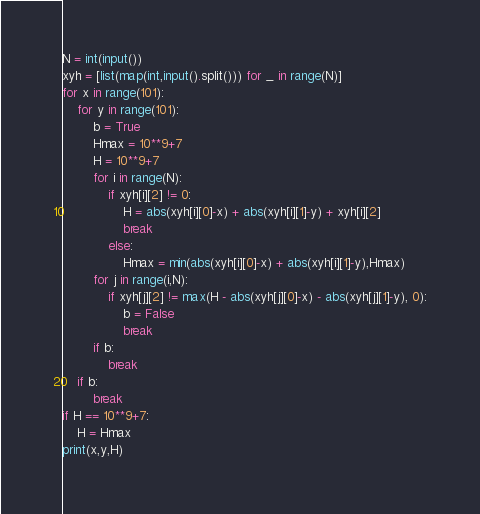Convert code to text. <code><loc_0><loc_0><loc_500><loc_500><_Python_>N = int(input())
xyh = [list(map(int,input().split())) for _ in range(N)]
for x in range(101):
    for y in range(101):
        b = True
        Hmax = 10**9+7
        H = 10**9+7
        for i in range(N):
            if xyh[i][2] != 0:
                H = abs(xyh[i][0]-x) + abs(xyh[i][1]-y) + xyh[i][2]
                break
            else:
                Hmax = min(abs(xyh[i][0]-x) + abs(xyh[i][1]-y),Hmax)
        for j in range(i,N):
            if xyh[j][2] != max(H - abs(xyh[j][0]-x) - abs(xyh[j][1]-y), 0):
                b = False
                break
        if b:
            break
    if b:
        break
if H == 10**9+7:
    H = Hmax
print(x,y,H)
</code> 